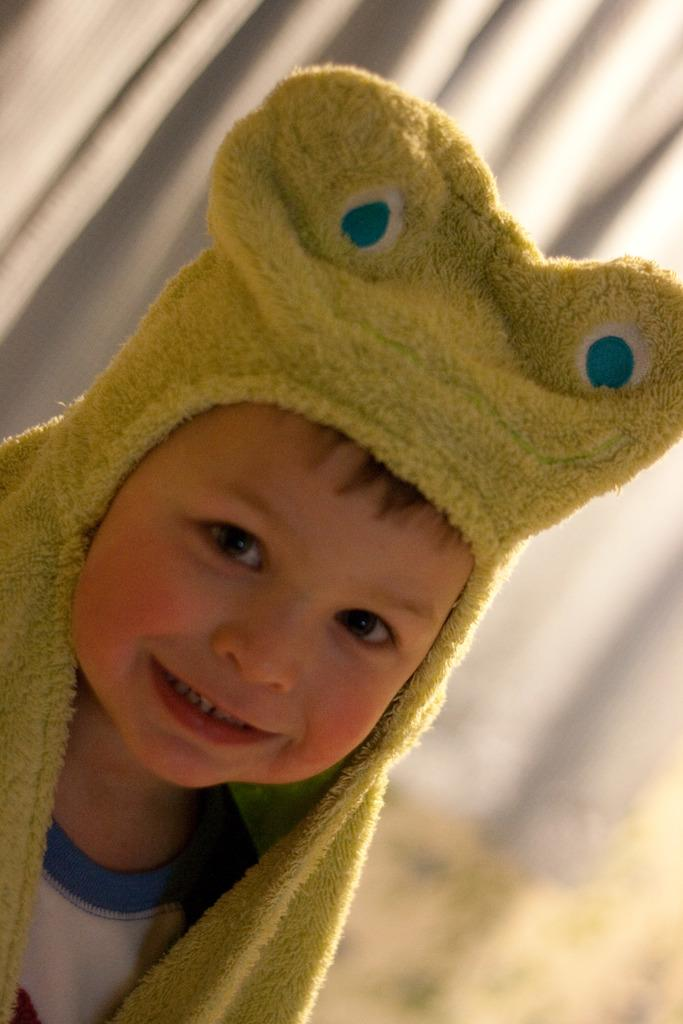What is the main subject of the picture? The main subject of the picture is a child. What is the child wearing in the picture? The child is wearing a sweater in the picture. What is the child's facial expression in the picture? The child is smiling in the picture. What type of art does the child create in the picture? There is no indication in the image that the child is creating any art, so it cannot be determined from the picture. 